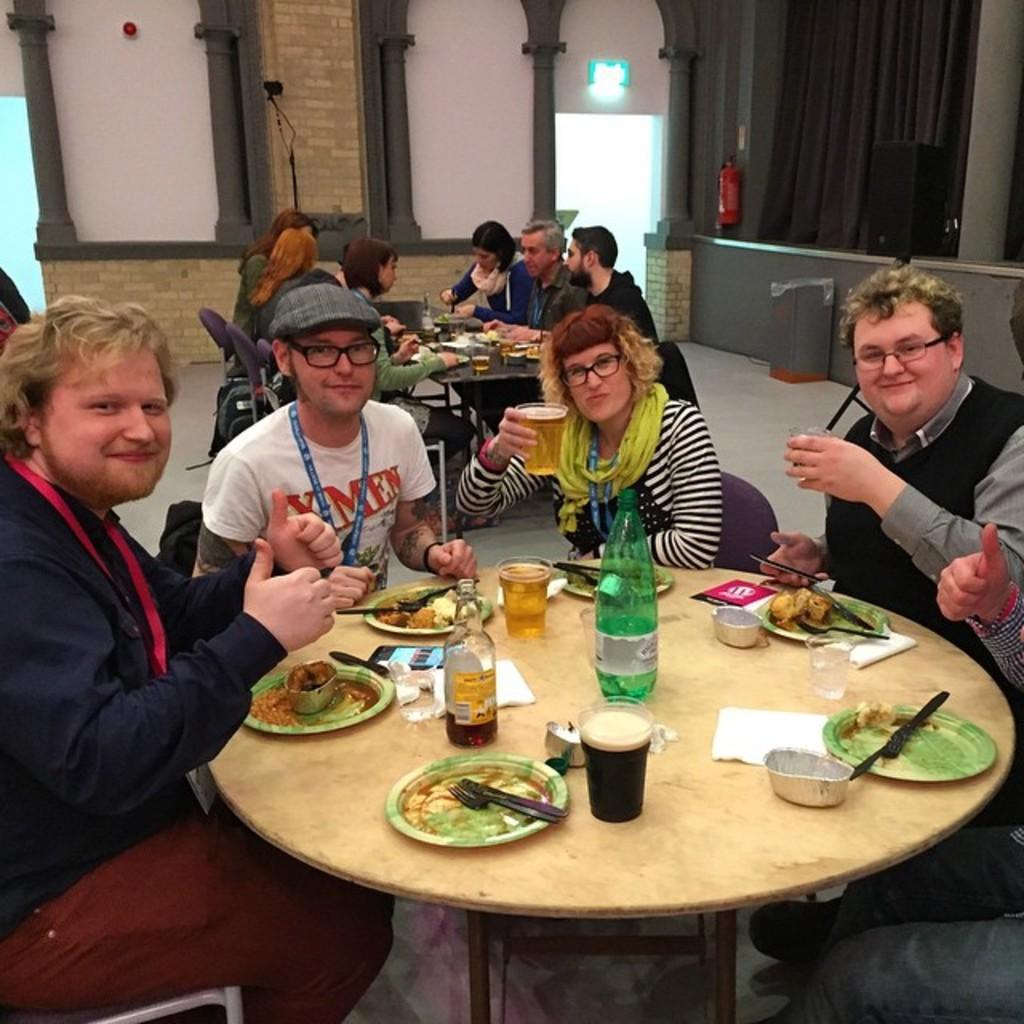In one or two sentences, can you explain what this image depicts? This is a picture taken in a room, there are a group of people sitting on a chair in front of these people there is a table on the table there are glasses, plate, fork,knife, mobile, bottle and tissues. Behind the people there is a wall and a fire extinguisher. 